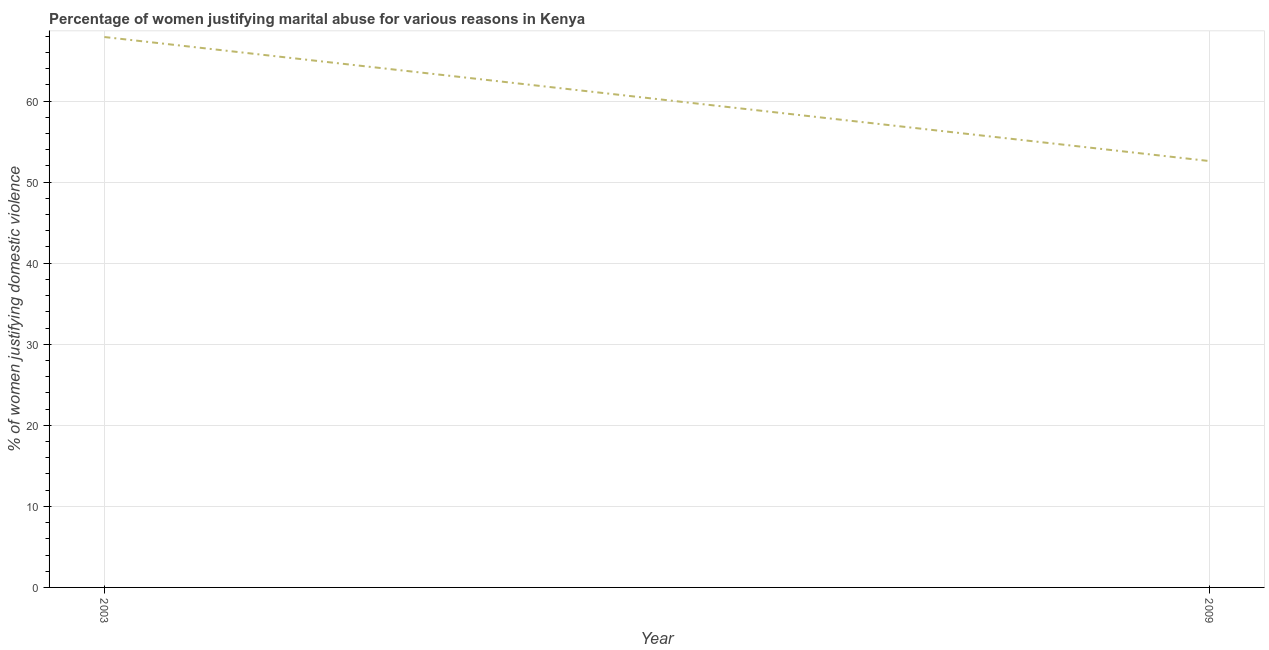What is the percentage of women justifying marital abuse in 2009?
Your answer should be very brief. 52.6. Across all years, what is the maximum percentage of women justifying marital abuse?
Offer a very short reply. 67.9. Across all years, what is the minimum percentage of women justifying marital abuse?
Keep it short and to the point. 52.6. In which year was the percentage of women justifying marital abuse maximum?
Your answer should be compact. 2003. In which year was the percentage of women justifying marital abuse minimum?
Provide a short and direct response. 2009. What is the sum of the percentage of women justifying marital abuse?
Make the answer very short. 120.5. What is the difference between the percentage of women justifying marital abuse in 2003 and 2009?
Provide a succinct answer. 15.3. What is the average percentage of women justifying marital abuse per year?
Offer a terse response. 60.25. What is the median percentage of women justifying marital abuse?
Offer a very short reply. 60.25. In how many years, is the percentage of women justifying marital abuse greater than 10 %?
Your response must be concise. 2. Do a majority of the years between 2009 and 2003 (inclusive) have percentage of women justifying marital abuse greater than 40 %?
Your answer should be very brief. No. What is the ratio of the percentage of women justifying marital abuse in 2003 to that in 2009?
Keep it short and to the point. 1.29. Is the percentage of women justifying marital abuse in 2003 less than that in 2009?
Provide a succinct answer. No. How many lines are there?
Make the answer very short. 1. How many years are there in the graph?
Offer a very short reply. 2. What is the difference between two consecutive major ticks on the Y-axis?
Your response must be concise. 10. Are the values on the major ticks of Y-axis written in scientific E-notation?
Provide a succinct answer. No. Does the graph contain any zero values?
Make the answer very short. No. Does the graph contain grids?
Offer a terse response. Yes. What is the title of the graph?
Make the answer very short. Percentage of women justifying marital abuse for various reasons in Kenya. What is the label or title of the X-axis?
Ensure brevity in your answer.  Year. What is the label or title of the Y-axis?
Your answer should be very brief. % of women justifying domestic violence. What is the % of women justifying domestic violence of 2003?
Ensure brevity in your answer.  67.9. What is the % of women justifying domestic violence in 2009?
Give a very brief answer. 52.6. What is the ratio of the % of women justifying domestic violence in 2003 to that in 2009?
Give a very brief answer. 1.29. 